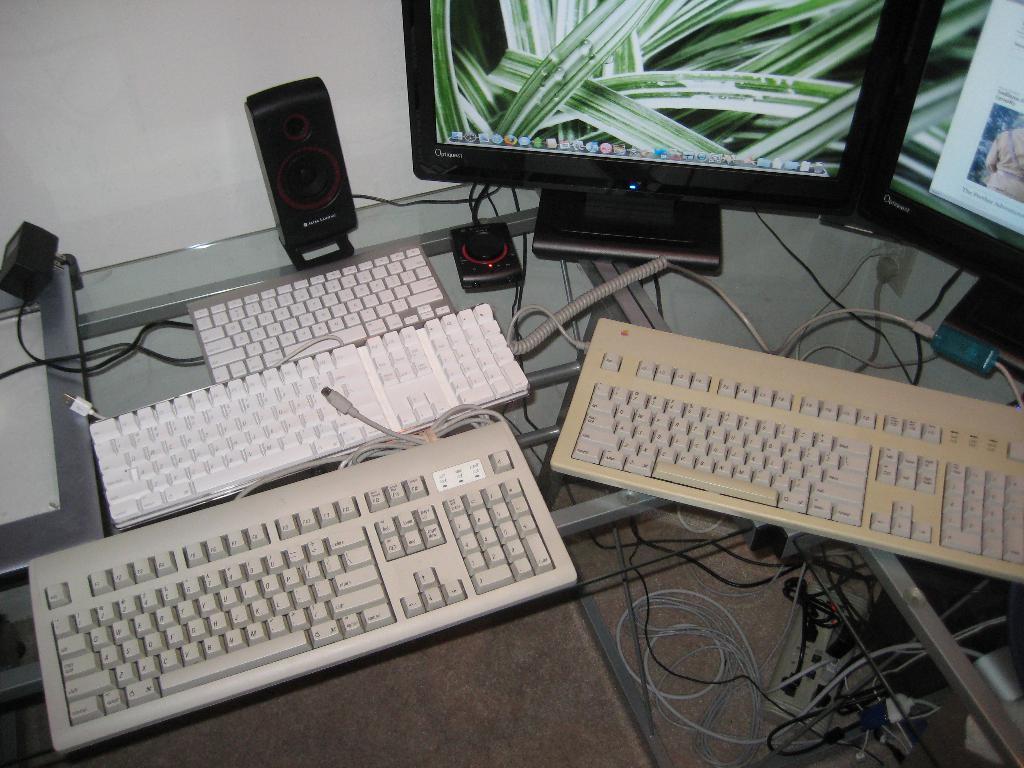How would you summarize this image in a sentence or two? In this picture there is a table at the bottom. On the table there are keyboards, monitors, wires and sound speakers are placed on the table. The table is transparent so, we can see the wires on the ground. 